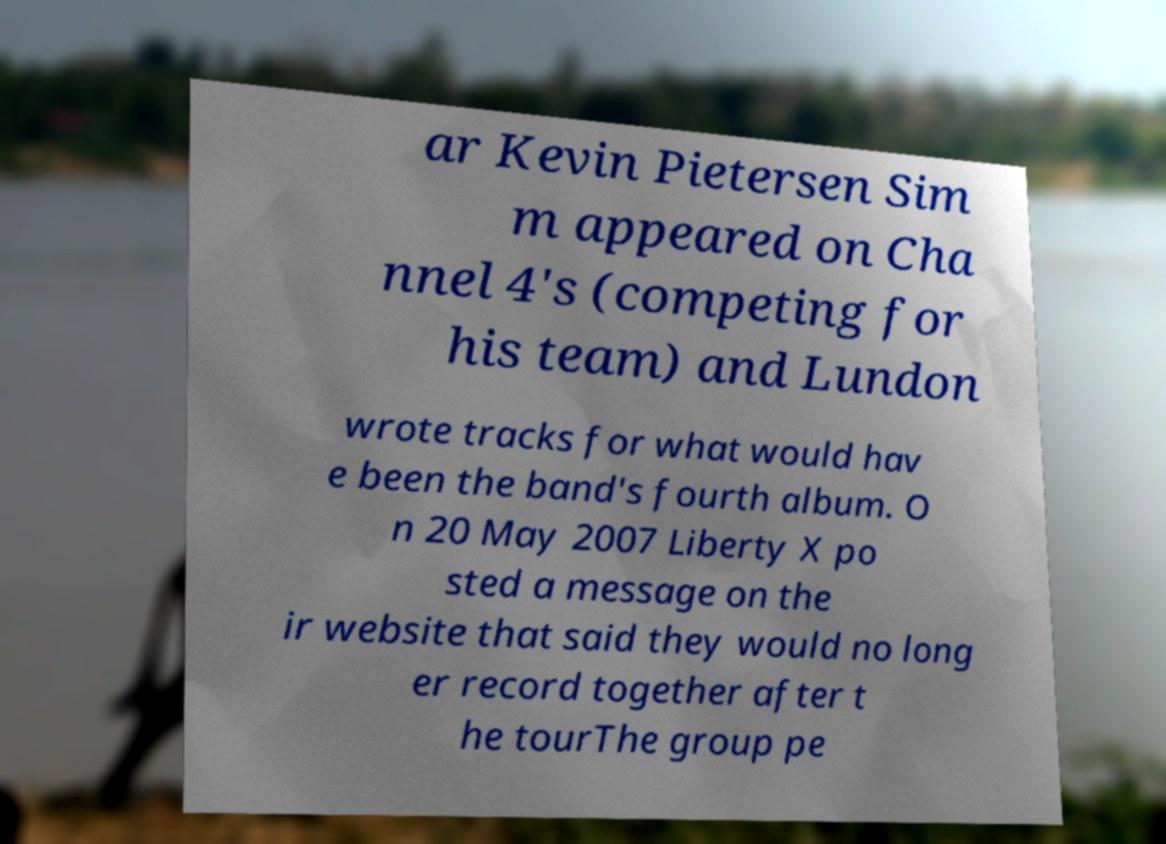Could you extract and type out the text from this image? ar Kevin Pietersen Sim m appeared on Cha nnel 4's (competing for his team) and Lundon wrote tracks for what would hav e been the band's fourth album. O n 20 May 2007 Liberty X po sted a message on the ir website that said they would no long er record together after t he tourThe group pe 